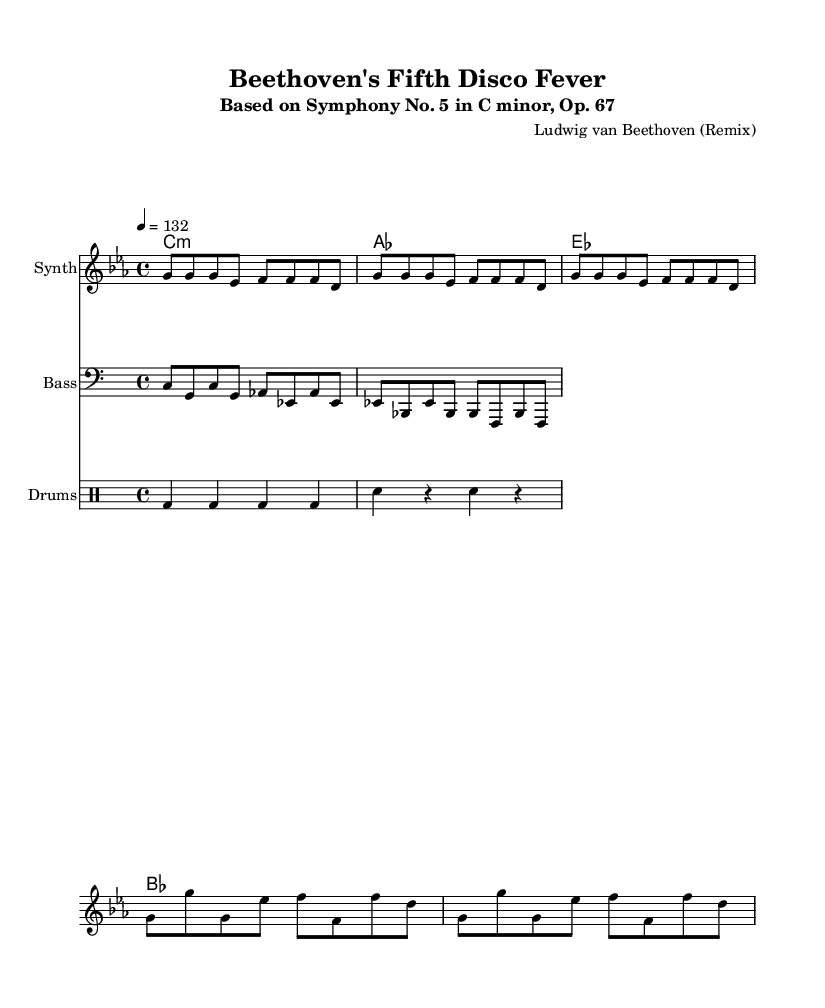What is the key signature of this music? The key signature is C minor, which has three flats (B♭, E♭, A♭) represented at the beginning of the staff.
Answer: C minor What is the time signature of this piece? The time signature is found at the beginning and is represented as 4/4, indicating four beats per measure and a quarter note receives one beat.
Answer: 4/4 What is the tempo marking given? The tempo marking is indicated in the score as "4 = 132," meaning there are 132 beats per minute.
Answer: 132 How many measures are in the Intro section? The Intro section consists of one measure with a total of eight eighth notes indicated in the rhythm.
Answer: 1 Which instrument has the melody? The melody is played by the "Synth," as indicated in the label on the staff.
Answer: Synth What type of bass pattern is used throughout the score? The bass pattern consists of a repetitive figure, characterized by a combination of eighth notes and the lower pitches of the chord changes.
Answer: Repetitive figure What instruments are used in this arrangement? The score includes "Synth," "Bass," and "Drums," representing the different layered sounds typical for a dance remix arrangement.
Answer: Synth, Bass, Drums 